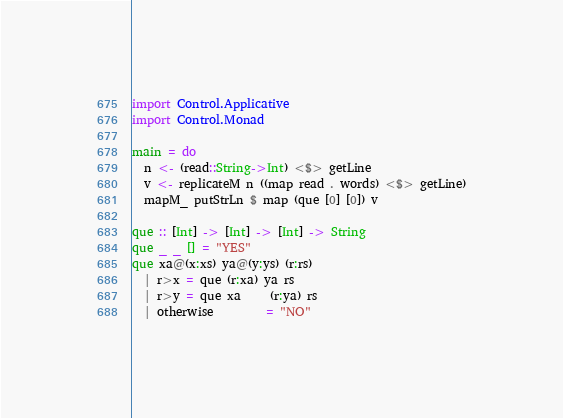Convert code to text. <code><loc_0><loc_0><loc_500><loc_500><_Haskell_>import Control.Applicative
import Control.Monad

main = do
  n <- (read::String->Int) <$> getLine
  v <- replicateM n ((map read . words) <$> getLine)
  mapM_ putStrLn $ map (que [0] [0]) v
            
que :: [Int] -> [Int] -> [Int] -> String
que _ _ [] = "YES"
que xa@(x:xs) ya@(y:ys) (r:rs)
  | r>x = que (r:xa) ya rs
  | r>y = que xa     (r:ya) rs
  | otherwise         = "NO"</code> 